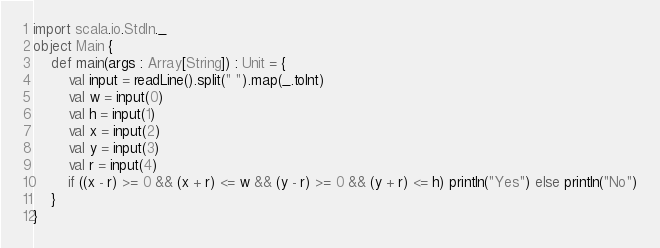<code> <loc_0><loc_0><loc_500><loc_500><_Scala_>import scala.io.StdIn._
object Main {
    def main(args : Array[String]) : Unit = {
        val input = readLine().split(" ").map(_.toInt)
        val w = input(0)
        val h = input(1)
        val x = input(2)
        val y = input(3)
        val r = input(4)
        if ((x - r) >= 0 && (x + r) <= w && (y - r) >= 0 && (y + r) <= h) println("Yes") else println("No")
    }
}</code> 